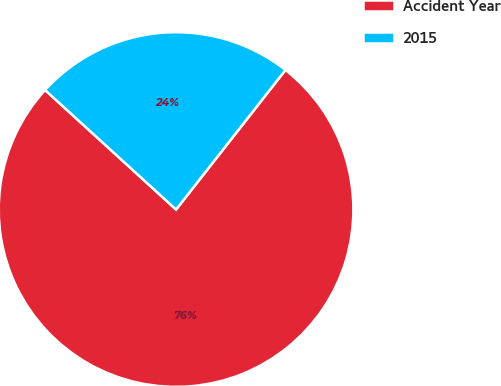Convert chart to OTSL. <chart><loc_0><loc_0><loc_500><loc_500><pie_chart><fcel>Accident Year<fcel>2015<nl><fcel>76.19%<fcel>23.81%<nl></chart> 